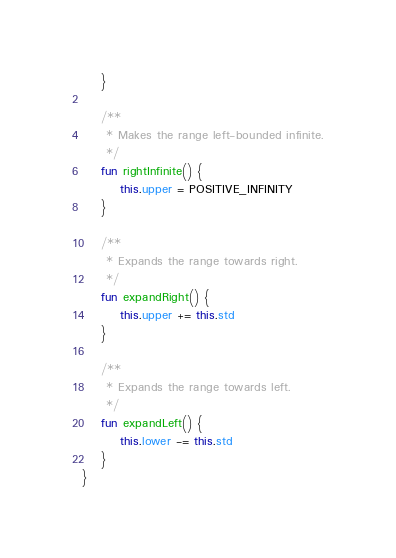<code> <loc_0><loc_0><loc_500><loc_500><_Kotlin_>    }

    /**
     * Makes the range left-bounded infinite.
     */
    fun rightInfinite() {
        this.upper = POSITIVE_INFINITY
    }

    /**
     * Expands the range towards right.
     */
    fun expandRight() {
        this.upper += this.std
    }

    /**
     * Expands the range towards left.
     */
    fun expandLeft() {
        this.lower -= this.std
    }
}
</code> 